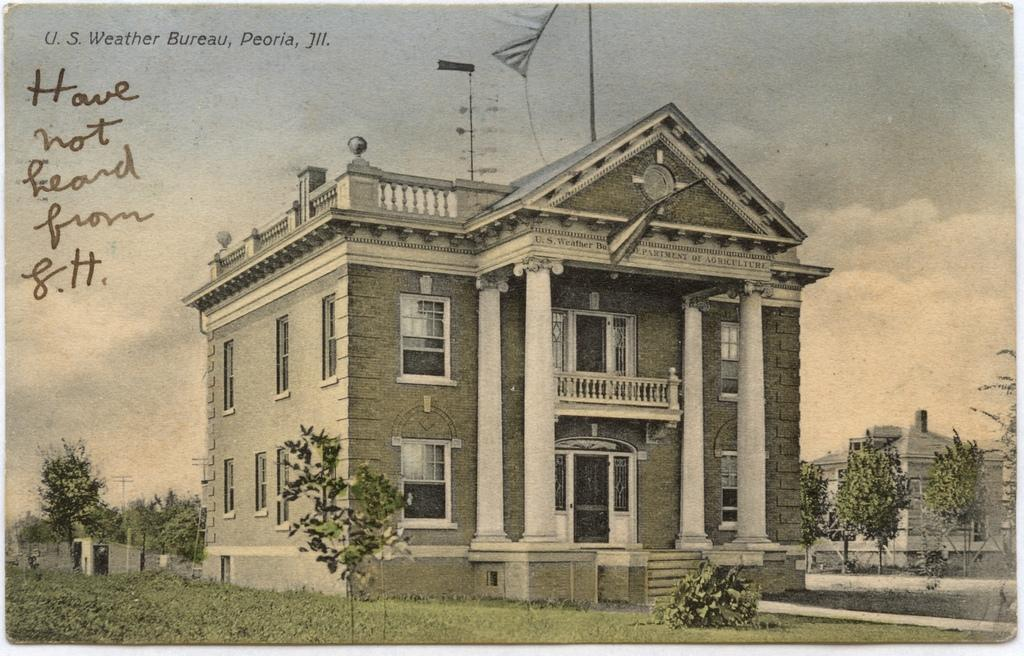What type of structure is visible in the image? There is a building in the image. What type of vegetation is present in the image? There are trees in the image. What covers the ground in the image? The ground is covered with grass. What type of butter is being used to fuel the building in the image? There is no butter or fuel present in the image; it features a building, trees, and grass. 